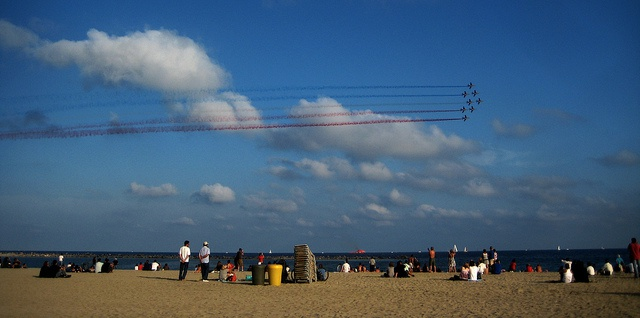Describe the objects in this image and their specific colors. I can see people in darkblue, black, olive, maroon, and gray tones, people in darkblue, black, gray, ivory, and darkgray tones, people in darkblue, black, darkgray, gray, and maroon tones, people in darkblue, black, maroon, gray, and tan tones, and people in darkblue, black, maroon, and gray tones in this image. 